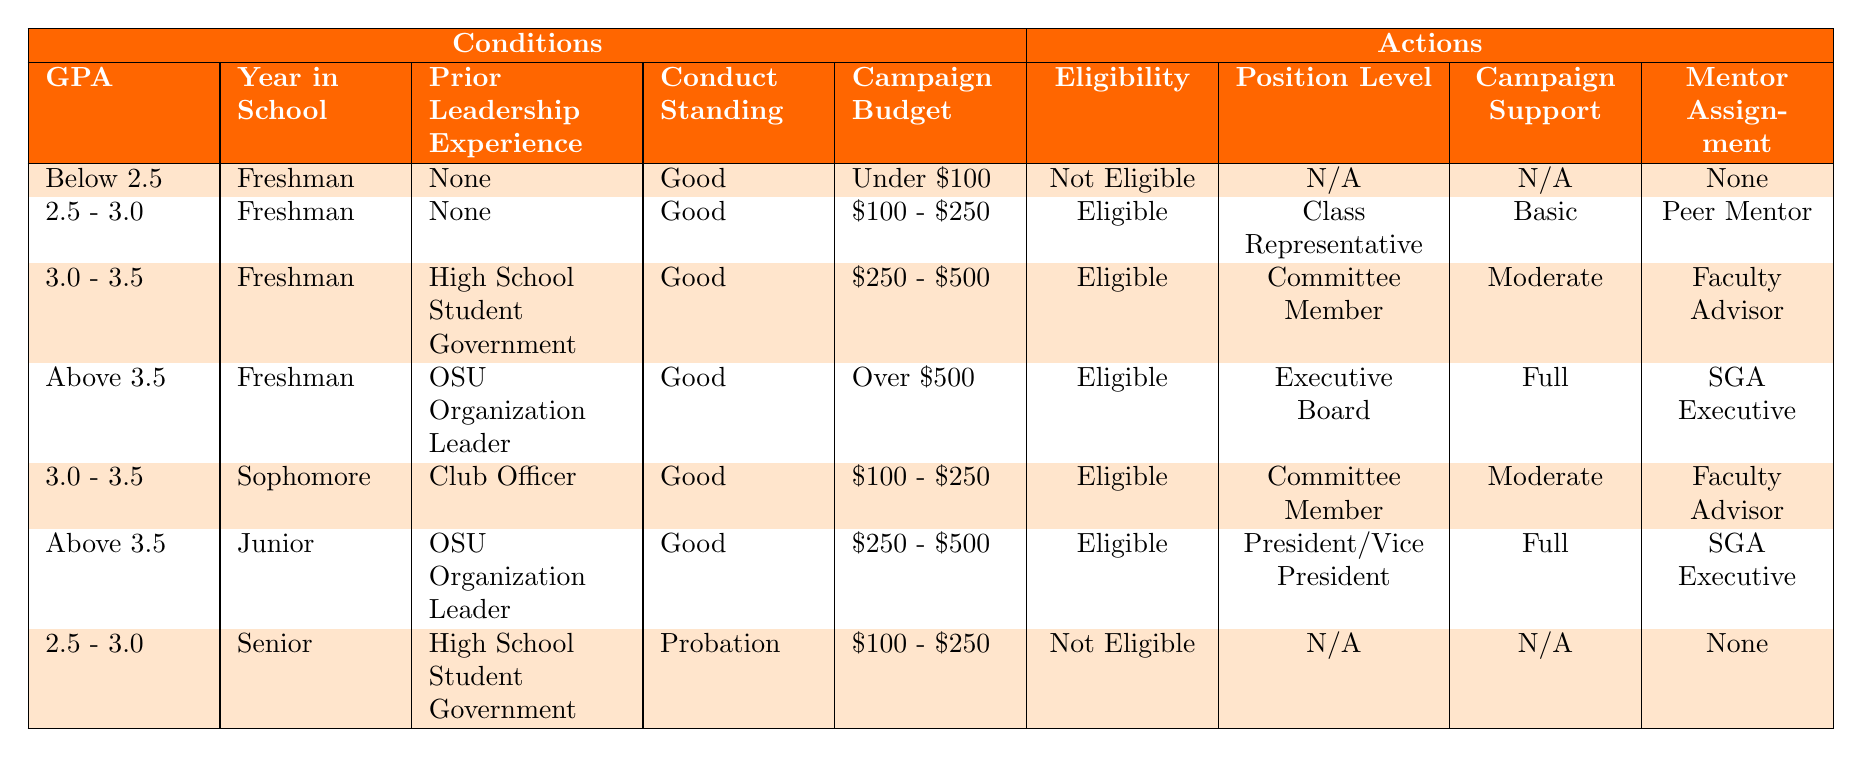What is the eligibility status for a Freshman with a GPA below 2.5? According to the table, a Freshman with a GPA below 2.5, who has no prior leadership experience, good conduct standing, and a campaign budget under $100, is marked as "Not Eligible."
Answer: Not Eligible What position can a Freshman with a GPA between 2.5 and 3.0 hold if they have no prior leadership experience? The table indicates that a Freshman with a GPA between 2.5 and 3.0 and no prior leadership experience is eligible to be a "Class Representative."
Answer: Class Representative Is a Junior with a GPA above 3.5 eligible for the position of President or Vice President? Yes, the table shows that a Junior with a GPA above 3.5, who is an OSU Organization Leader, is "Eligible" for the position of President/Vice President.
Answer: Yes What is the campaign support level for a Freshman with prior experience in High School Student Government and a budget of $250 to $500? According to the table, a Freshman with a GPA between 3.0 and 3.5, prior High School Student Government experience, good conduct, and a campaign budget of $250 to $500, has "Moderate" campaign support.
Answer: Moderate How many distinct eligibility statuses are present in the table? The table presents two distinct eligibility statuses: "Eligible" and "Not Eligible." These statuses are found in multiple rows, but the distinct count is just two.
Answer: 2 What is the mentor assignment for a Sophomore with a GPA between 3.0 and 3.5? The table indicates that a Sophomore with a GPA between 3.0 and 3.5, having prior experience as a Club Officer, is assigned a "Faculty Advisor."
Answer: Faculty Advisor If a Freshman has a campaign budget over $500, what is the eligibility and position they can hold assuming they have prior experience as an OSU Organization Leader? The table specifies that a Freshman with a campaign budget over $500 and prior experience as an OSU Organization Leader is "Eligible," with the position level of "Executive Board."
Answer: Eligible, Executive Board Do any Senior students in probationary conduct status qualify for eligibility? No, the table shows that a Senior with a GPA between 2.5 and 3.0, prior experience in High School Student Government, and on probation is marked as "Not Eligible."
Answer: No 